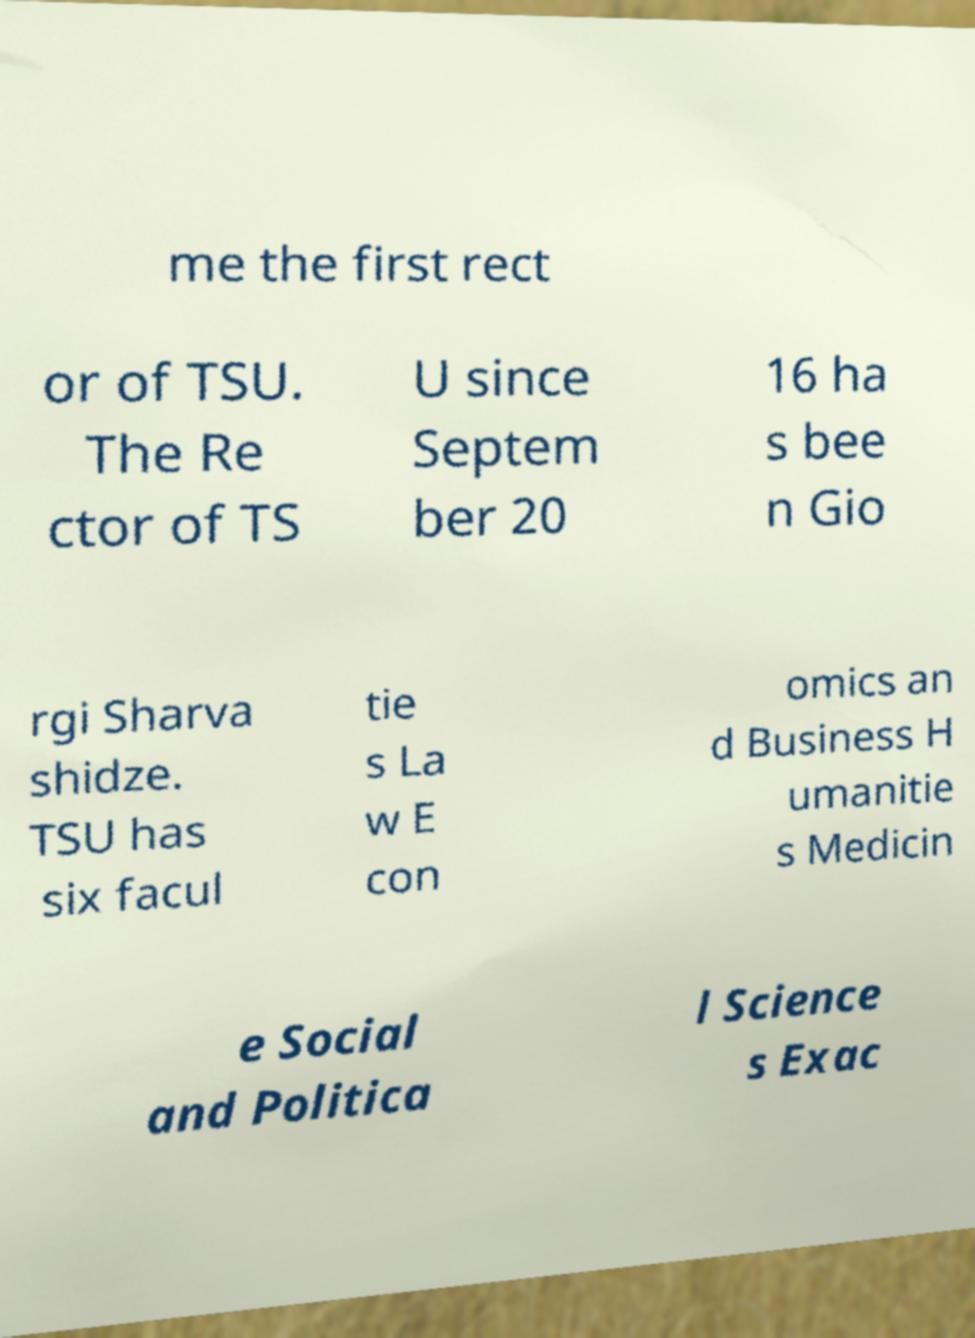I need the written content from this picture converted into text. Can you do that? me the first rect or of TSU. The Re ctor of TS U since Septem ber 20 16 ha s bee n Gio rgi Sharva shidze. TSU has six facul tie s La w E con omics an d Business H umanitie s Medicin e Social and Politica l Science s Exac 